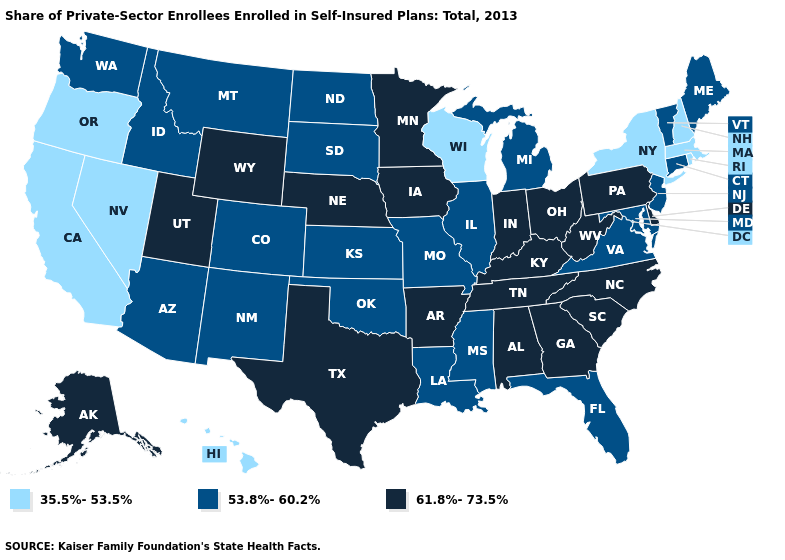Which states have the lowest value in the South?
Keep it brief. Florida, Louisiana, Maryland, Mississippi, Oklahoma, Virginia. Which states hav the highest value in the South?
Keep it brief. Alabama, Arkansas, Delaware, Georgia, Kentucky, North Carolina, South Carolina, Tennessee, Texas, West Virginia. Does Utah have the highest value in the West?
Keep it brief. Yes. What is the value of Mississippi?
Give a very brief answer. 53.8%-60.2%. Among the states that border Alabama , which have the highest value?
Quick response, please. Georgia, Tennessee. Among the states that border Delaware , does New Jersey have the lowest value?
Write a very short answer. Yes. Name the states that have a value in the range 61.8%-73.5%?
Keep it brief. Alabama, Alaska, Arkansas, Delaware, Georgia, Indiana, Iowa, Kentucky, Minnesota, Nebraska, North Carolina, Ohio, Pennsylvania, South Carolina, Tennessee, Texas, Utah, West Virginia, Wyoming. What is the highest value in states that border Maine?
Concise answer only. 35.5%-53.5%. What is the highest value in the USA?
Give a very brief answer. 61.8%-73.5%. What is the value of Vermont?
Give a very brief answer. 53.8%-60.2%. Which states have the lowest value in the USA?
Quick response, please. California, Hawaii, Massachusetts, Nevada, New Hampshire, New York, Oregon, Rhode Island, Wisconsin. Does Colorado have the same value as Washington?
Quick response, please. Yes. What is the lowest value in states that border Idaho?
Write a very short answer. 35.5%-53.5%. What is the highest value in states that border California?
Concise answer only. 53.8%-60.2%. 